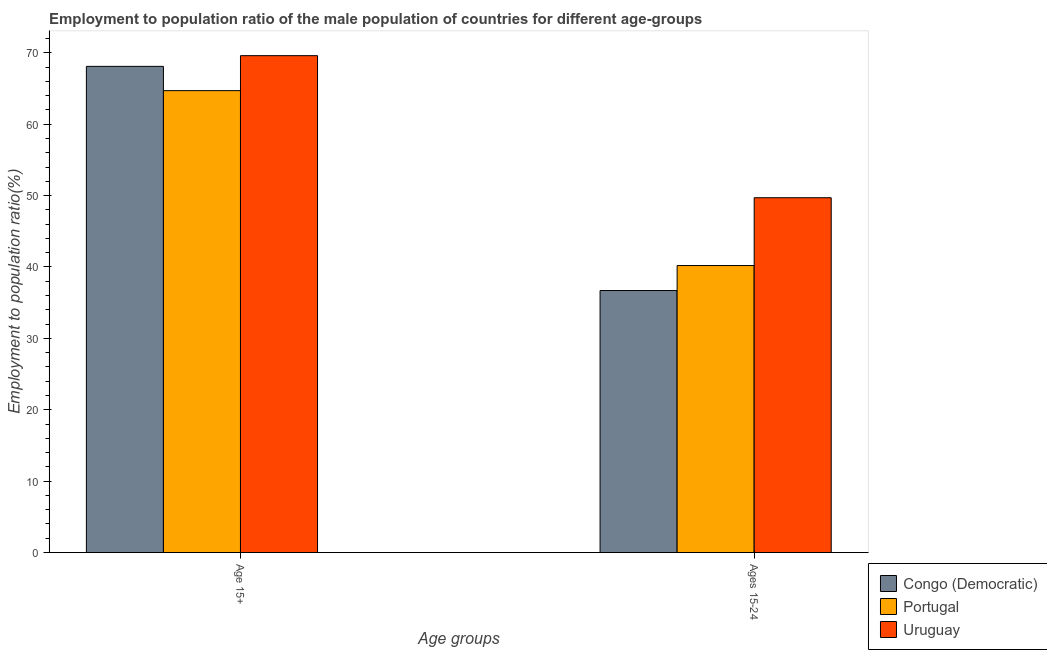How many different coloured bars are there?
Keep it short and to the point. 3. Are the number of bars per tick equal to the number of legend labels?
Provide a short and direct response. Yes. How many bars are there on the 1st tick from the right?
Give a very brief answer. 3. What is the label of the 2nd group of bars from the left?
Your response must be concise. Ages 15-24. What is the employment to population ratio(age 15-24) in Uruguay?
Ensure brevity in your answer.  49.7. Across all countries, what is the maximum employment to population ratio(age 15-24)?
Provide a succinct answer. 49.7. Across all countries, what is the minimum employment to population ratio(age 15-24)?
Provide a short and direct response. 36.7. In which country was the employment to population ratio(age 15-24) maximum?
Your response must be concise. Uruguay. What is the total employment to population ratio(age 15+) in the graph?
Your answer should be very brief. 202.4. What is the difference between the employment to population ratio(age 15+) in Congo (Democratic) and that in Portugal?
Make the answer very short. 3.4. What is the difference between the employment to population ratio(age 15+) in Uruguay and the employment to population ratio(age 15-24) in Portugal?
Your response must be concise. 29.4. What is the average employment to population ratio(age 15-24) per country?
Your answer should be very brief. 42.2. What is the difference between the employment to population ratio(age 15-24) and employment to population ratio(age 15+) in Congo (Democratic)?
Your answer should be compact. -31.4. In how many countries, is the employment to population ratio(age 15+) greater than 26 %?
Provide a short and direct response. 3. What is the ratio of the employment to population ratio(age 15+) in Congo (Democratic) to that in Uruguay?
Your answer should be very brief. 0.98. In how many countries, is the employment to population ratio(age 15+) greater than the average employment to population ratio(age 15+) taken over all countries?
Provide a short and direct response. 2. Are all the bars in the graph horizontal?
Your answer should be very brief. No. Does the graph contain grids?
Provide a short and direct response. No. How are the legend labels stacked?
Keep it short and to the point. Vertical. What is the title of the graph?
Ensure brevity in your answer.  Employment to population ratio of the male population of countries for different age-groups. What is the label or title of the X-axis?
Provide a succinct answer. Age groups. What is the label or title of the Y-axis?
Your response must be concise. Employment to population ratio(%). What is the Employment to population ratio(%) in Congo (Democratic) in Age 15+?
Make the answer very short. 68.1. What is the Employment to population ratio(%) of Portugal in Age 15+?
Your response must be concise. 64.7. What is the Employment to population ratio(%) in Uruguay in Age 15+?
Offer a very short reply. 69.6. What is the Employment to population ratio(%) in Congo (Democratic) in Ages 15-24?
Provide a succinct answer. 36.7. What is the Employment to population ratio(%) in Portugal in Ages 15-24?
Keep it short and to the point. 40.2. What is the Employment to population ratio(%) in Uruguay in Ages 15-24?
Give a very brief answer. 49.7. Across all Age groups, what is the maximum Employment to population ratio(%) of Congo (Democratic)?
Offer a terse response. 68.1. Across all Age groups, what is the maximum Employment to population ratio(%) in Portugal?
Your answer should be compact. 64.7. Across all Age groups, what is the maximum Employment to population ratio(%) in Uruguay?
Provide a succinct answer. 69.6. Across all Age groups, what is the minimum Employment to population ratio(%) of Congo (Democratic)?
Provide a succinct answer. 36.7. Across all Age groups, what is the minimum Employment to population ratio(%) in Portugal?
Offer a terse response. 40.2. Across all Age groups, what is the minimum Employment to population ratio(%) in Uruguay?
Your answer should be compact. 49.7. What is the total Employment to population ratio(%) of Congo (Democratic) in the graph?
Make the answer very short. 104.8. What is the total Employment to population ratio(%) in Portugal in the graph?
Provide a short and direct response. 104.9. What is the total Employment to population ratio(%) in Uruguay in the graph?
Your response must be concise. 119.3. What is the difference between the Employment to population ratio(%) of Congo (Democratic) in Age 15+ and that in Ages 15-24?
Provide a succinct answer. 31.4. What is the difference between the Employment to population ratio(%) in Portugal in Age 15+ and that in Ages 15-24?
Offer a terse response. 24.5. What is the difference between the Employment to population ratio(%) in Congo (Democratic) in Age 15+ and the Employment to population ratio(%) in Portugal in Ages 15-24?
Offer a terse response. 27.9. What is the difference between the Employment to population ratio(%) of Congo (Democratic) in Age 15+ and the Employment to population ratio(%) of Uruguay in Ages 15-24?
Ensure brevity in your answer.  18.4. What is the difference between the Employment to population ratio(%) of Portugal in Age 15+ and the Employment to population ratio(%) of Uruguay in Ages 15-24?
Offer a very short reply. 15. What is the average Employment to population ratio(%) in Congo (Democratic) per Age groups?
Your answer should be compact. 52.4. What is the average Employment to population ratio(%) of Portugal per Age groups?
Keep it short and to the point. 52.45. What is the average Employment to population ratio(%) of Uruguay per Age groups?
Give a very brief answer. 59.65. What is the difference between the Employment to population ratio(%) in Congo (Democratic) and Employment to population ratio(%) in Uruguay in Age 15+?
Your response must be concise. -1.5. What is the difference between the Employment to population ratio(%) in Portugal and Employment to population ratio(%) in Uruguay in Age 15+?
Ensure brevity in your answer.  -4.9. What is the difference between the Employment to population ratio(%) in Portugal and Employment to population ratio(%) in Uruguay in Ages 15-24?
Ensure brevity in your answer.  -9.5. What is the ratio of the Employment to population ratio(%) in Congo (Democratic) in Age 15+ to that in Ages 15-24?
Offer a terse response. 1.86. What is the ratio of the Employment to population ratio(%) in Portugal in Age 15+ to that in Ages 15-24?
Provide a short and direct response. 1.61. What is the ratio of the Employment to population ratio(%) of Uruguay in Age 15+ to that in Ages 15-24?
Keep it short and to the point. 1.4. What is the difference between the highest and the second highest Employment to population ratio(%) of Congo (Democratic)?
Offer a terse response. 31.4. What is the difference between the highest and the second highest Employment to population ratio(%) in Uruguay?
Your answer should be compact. 19.9. What is the difference between the highest and the lowest Employment to population ratio(%) in Congo (Democratic)?
Your response must be concise. 31.4. 